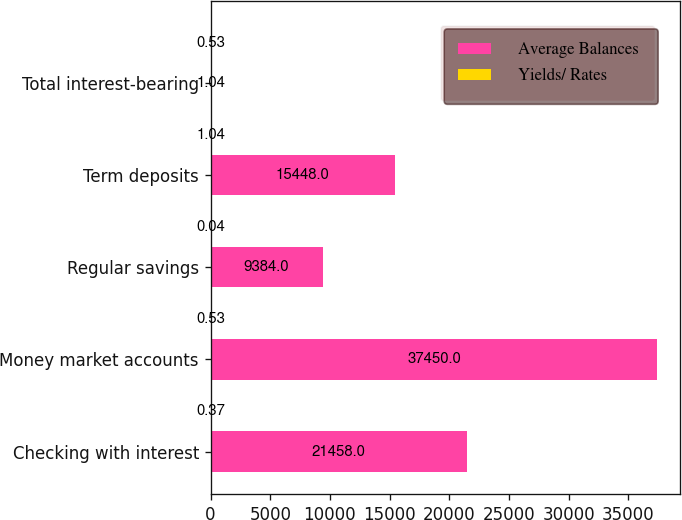Convert chart to OTSL. <chart><loc_0><loc_0><loc_500><loc_500><stacked_bar_chart><ecel><fcel>Checking with interest<fcel>Money market accounts<fcel>Regular savings<fcel>Term deposits<fcel>Total interest-bearing<nl><fcel>Average Balances<fcel>21458<fcel>37450<fcel>9384<fcel>15448<fcel>1.04<nl><fcel>Yields/ Rates<fcel>0.37<fcel>0.53<fcel>0.04<fcel>1.04<fcel>0.53<nl></chart> 